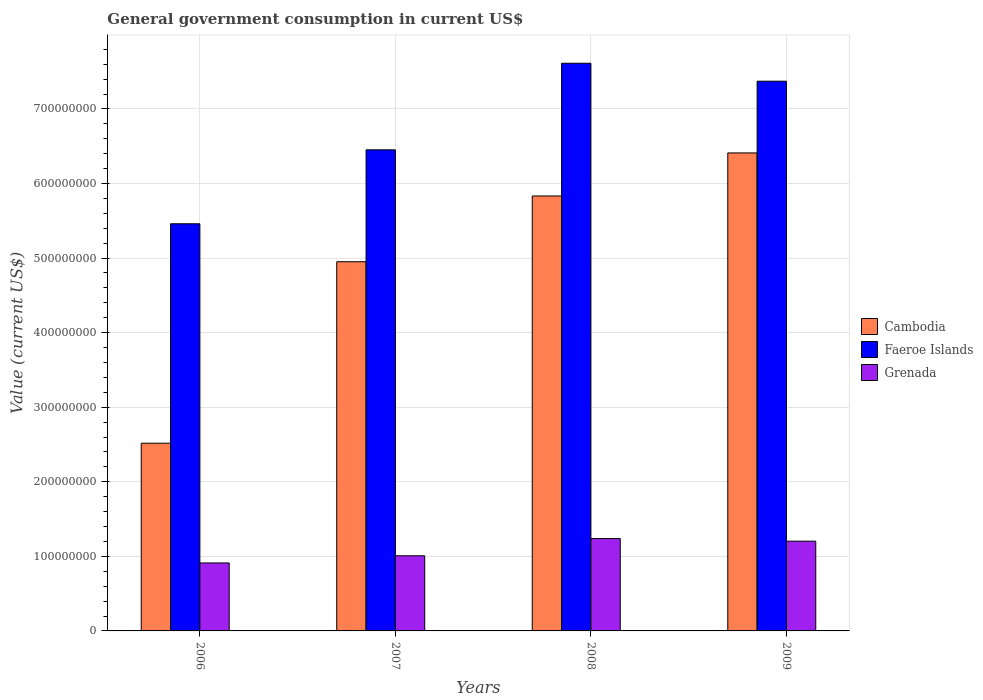How many bars are there on the 1st tick from the left?
Ensure brevity in your answer.  3. What is the label of the 3rd group of bars from the left?
Provide a short and direct response. 2008. In how many cases, is the number of bars for a given year not equal to the number of legend labels?
Provide a short and direct response. 0. What is the government conusmption in Cambodia in 2009?
Provide a short and direct response. 6.41e+08. Across all years, what is the maximum government conusmption in Faeroe Islands?
Give a very brief answer. 7.61e+08. Across all years, what is the minimum government conusmption in Cambodia?
Provide a succinct answer. 2.52e+08. In which year was the government conusmption in Cambodia minimum?
Your answer should be very brief. 2006. What is the total government conusmption in Faeroe Islands in the graph?
Your response must be concise. 2.69e+09. What is the difference between the government conusmption in Cambodia in 2006 and that in 2008?
Make the answer very short. -3.32e+08. What is the difference between the government conusmption in Faeroe Islands in 2009 and the government conusmption in Cambodia in 2006?
Your answer should be very brief. 4.85e+08. What is the average government conusmption in Cambodia per year?
Keep it short and to the point. 4.93e+08. In the year 2006, what is the difference between the government conusmption in Faeroe Islands and government conusmption in Grenada?
Your response must be concise. 4.55e+08. In how many years, is the government conusmption in Grenada greater than 140000000 US$?
Offer a terse response. 0. What is the ratio of the government conusmption in Faeroe Islands in 2006 to that in 2009?
Keep it short and to the point. 0.74. Is the government conusmption in Faeroe Islands in 2006 less than that in 2007?
Keep it short and to the point. Yes. Is the difference between the government conusmption in Faeroe Islands in 2007 and 2009 greater than the difference between the government conusmption in Grenada in 2007 and 2009?
Give a very brief answer. No. What is the difference between the highest and the second highest government conusmption in Faeroe Islands?
Your answer should be very brief. 2.41e+07. What is the difference between the highest and the lowest government conusmption in Faeroe Islands?
Give a very brief answer. 2.15e+08. What does the 2nd bar from the left in 2009 represents?
Your answer should be very brief. Faeroe Islands. What does the 1st bar from the right in 2007 represents?
Your response must be concise. Grenada. Is it the case that in every year, the sum of the government conusmption in Cambodia and government conusmption in Grenada is greater than the government conusmption in Faeroe Islands?
Provide a short and direct response. No. Are the values on the major ticks of Y-axis written in scientific E-notation?
Your answer should be compact. No. Does the graph contain any zero values?
Provide a succinct answer. No. How are the legend labels stacked?
Make the answer very short. Vertical. What is the title of the graph?
Offer a terse response. General government consumption in current US$. What is the label or title of the Y-axis?
Offer a terse response. Value (current US$). What is the Value (current US$) of Cambodia in 2006?
Keep it short and to the point. 2.52e+08. What is the Value (current US$) of Faeroe Islands in 2006?
Offer a terse response. 5.46e+08. What is the Value (current US$) in Grenada in 2006?
Offer a terse response. 9.11e+07. What is the Value (current US$) of Cambodia in 2007?
Give a very brief answer. 4.95e+08. What is the Value (current US$) of Faeroe Islands in 2007?
Give a very brief answer. 6.45e+08. What is the Value (current US$) in Grenada in 2007?
Make the answer very short. 1.01e+08. What is the Value (current US$) of Cambodia in 2008?
Your answer should be compact. 5.83e+08. What is the Value (current US$) of Faeroe Islands in 2008?
Offer a terse response. 7.61e+08. What is the Value (current US$) of Grenada in 2008?
Make the answer very short. 1.24e+08. What is the Value (current US$) in Cambodia in 2009?
Your answer should be compact. 6.41e+08. What is the Value (current US$) of Faeroe Islands in 2009?
Make the answer very short. 7.37e+08. What is the Value (current US$) in Grenada in 2009?
Give a very brief answer. 1.20e+08. Across all years, what is the maximum Value (current US$) in Cambodia?
Ensure brevity in your answer.  6.41e+08. Across all years, what is the maximum Value (current US$) in Faeroe Islands?
Ensure brevity in your answer.  7.61e+08. Across all years, what is the maximum Value (current US$) of Grenada?
Give a very brief answer. 1.24e+08. Across all years, what is the minimum Value (current US$) of Cambodia?
Keep it short and to the point. 2.52e+08. Across all years, what is the minimum Value (current US$) of Faeroe Islands?
Give a very brief answer. 5.46e+08. Across all years, what is the minimum Value (current US$) of Grenada?
Offer a very short reply. 9.11e+07. What is the total Value (current US$) in Cambodia in the graph?
Keep it short and to the point. 1.97e+09. What is the total Value (current US$) of Faeroe Islands in the graph?
Offer a very short reply. 2.69e+09. What is the total Value (current US$) in Grenada in the graph?
Provide a short and direct response. 4.36e+08. What is the difference between the Value (current US$) of Cambodia in 2006 and that in 2007?
Keep it short and to the point. -2.43e+08. What is the difference between the Value (current US$) of Faeroe Islands in 2006 and that in 2007?
Provide a short and direct response. -9.91e+07. What is the difference between the Value (current US$) in Grenada in 2006 and that in 2007?
Your answer should be compact. -9.65e+06. What is the difference between the Value (current US$) of Cambodia in 2006 and that in 2008?
Provide a short and direct response. -3.32e+08. What is the difference between the Value (current US$) in Faeroe Islands in 2006 and that in 2008?
Give a very brief answer. -2.15e+08. What is the difference between the Value (current US$) in Grenada in 2006 and that in 2008?
Your response must be concise. -3.27e+07. What is the difference between the Value (current US$) in Cambodia in 2006 and that in 2009?
Your response must be concise. -3.89e+08. What is the difference between the Value (current US$) in Faeroe Islands in 2006 and that in 2009?
Your answer should be compact. -1.91e+08. What is the difference between the Value (current US$) in Grenada in 2006 and that in 2009?
Give a very brief answer. -2.92e+07. What is the difference between the Value (current US$) of Cambodia in 2007 and that in 2008?
Make the answer very short. -8.82e+07. What is the difference between the Value (current US$) in Faeroe Islands in 2007 and that in 2008?
Keep it short and to the point. -1.16e+08. What is the difference between the Value (current US$) in Grenada in 2007 and that in 2008?
Your answer should be compact. -2.31e+07. What is the difference between the Value (current US$) in Cambodia in 2007 and that in 2009?
Give a very brief answer. -1.46e+08. What is the difference between the Value (current US$) of Faeroe Islands in 2007 and that in 2009?
Offer a terse response. -9.20e+07. What is the difference between the Value (current US$) in Grenada in 2007 and that in 2009?
Ensure brevity in your answer.  -1.96e+07. What is the difference between the Value (current US$) of Cambodia in 2008 and that in 2009?
Offer a terse response. -5.77e+07. What is the difference between the Value (current US$) in Faeroe Islands in 2008 and that in 2009?
Give a very brief answer. 2.41e+07. What is the difference between the Value (current US$) of Grenada in 2008 and that in 2009?
Provide a succinct answer. 3.51e+06. What is the difference between the Value (current US$) of Cambodia in 2006 and the Value (current US$) of Faeroe Islands in 2007?
Offer a very short reply. -3.93e+08. What is the difference between the Value (current US$) in Cambodia in 2006 and the Value (current US$) in Grenada in 2007?
Keep it short and to the point. 1.51e+08. What is the difference between the Value (current US$) in Faeroe Islands in 2006 and the Value (current US$) in Grenada in 2007?
Provide a short and direct response. 4.45e+08. What is the difference between the Value (current US$) of Cambodia in 2006 and the Value (current US$) of Faeroe Islands in 2008?
Ensure brevity in your answer.  -5.10e+08. What is the difference between the Value (current US$) of Cambodia in 2006 and the Value (current US$) of Grenada in 2008?
Offer a terse response. 1.28e+08. What is the difference between the Value (current US$) of Faeroe Islands in 2006 and the Value (current US$) of Grenada in 2008?
Provide a short and direct response. 4.22e+08. What is the difference between the Value (current US$) in Cambodia in 2006 and the Value (current US$) in Faeroe Islands in 2009?
Your answer should be compact. -4.85e+08. What is the difference between the Value (current US$) of Cambodia in 2006 and the Value (current US$) of Grenada in 2009?
Provide a short and direct response. 1.31e+08. What is the difference between the Value (current US$) of Faeroe Islands in 2006 and the Value (current US$) of Grenada in 2009?
Your answer should be very brief. 4.26e+08. What is the difference between the Value (current US$) of Cambodia in 2007 and the Value (current US$) of Faeroe Islands in 2008?
Provide a short and direct response. -2.66e+08. What is the difference between the Value (current US$) in Cambodia in 2007 and the Value (current US$) in Grenada in 2008?
Keep it short and to the point. 3.71e+08. What is the difference between the Value (current US$) in Faeroe Islands in 2007 and the Value (current US$) in Grenada in 2008?
Your response must be concise. 5.21e+08. What is the difference between the Value (current US$) in Cambodia in 2007 and the Value (current US$) in Faeroe Islands in 2009?
Provide a short and direct response. -2.42e+08. What is the difference between the Value (current US$) in Cambodia in 2007 and the Value (current US$) in Grenada in 2009?
Make the answer very short. 3.75e+08. What is the difference between the Value (current US$) in Faeroe Islands in 2007 and the Value (current US$) in Grenada in 2009?
Provide a succinct answer. 5.25e+08. What is the difference between the Value (current US$) of Cambodia in 2008 and the Value (current US$) of Faeroe Islands in 2009?
Provide a short and direct response. -1.54e+08. What is the difference between the Value (current US$) in Cambodia in 2008 and the Value (current US$) in Grenada in 2009?
Your answer should be compact. 4.63e+08. What is the difference between the Value (current US$) in Faeroe Islands in 2008 and the Value (current US$) in Grenada in 2009?
Your answer should be compact. 6.41e+08. What is the average Value (current US$) of Cambodia per year?
Your answer should be very brief. 4.93e+08. What is the average Value (current US$) of Faeroe Islands per year?
Your answer should be very brief. 6.72e+08. What is the average Value (current US$) of Grenada per year?
Provide a succinct answer. 1.09e+08. In the year 2006, what is the difference between the Value (current US$) of Cambodia and Value (current US$) of Faeroe Islands?
Provide a short and direct response. -2.94e+08. In the year 2006, what is the difference between the Value (current US$) of Cambodia and Value (current US$) of Grenada?
Offer a terse response. 1.61e+08. In the year 2006, what is the difference between the Value (current US$) of Faeroe Islands and Value (current US$) of Grenada?
Provide a short and direct response. 4.55e+08. In the year 2007, what is the difference between the Value (current US$) of Cambodia and Value (current US$) of Faeroe Islands?
Ensure brevity in your answer.  -1.50e+08. In the year 2007, what is the difference between the Value (current US$) in Cambodia and Value (current US$) in Grenada?
Offer a terse response. 3.94e+08. In the year 2007, what is the difference between the Value (current US$) in Faeroe Islands and Value (current US$) in Grenada?
Provide a succinct answer. 5.44e+08. In the year 2008, what is the difference between the Value (current US$) in Cambodia and Value (current US$) in Faeroe Islands?
Give a very brief answer. -1.78e+08. In the year 2008, what is the difference between the Value (current US$) of Cambodia and Value (current US$) of Grenada?
Your answer should be very brief. 4.59e+08. In the year 2008, what is the difference between the Value (current US$) in Faeroe Islands and Value (current US$) in Grenada?
Your response must be concise. 6.37e+08. In the year 2009, what is the difference between the Value (current US$) in Cambodia and Value (current US$) in Faeroe Islands?
Make the answer very short. -9.62e+07. In the year 2009, what is the difference between the Value (current US$) of Cambodia and Value (current US$) of Grenada?
Offer a terse response. 5.21e+08. In the year 2009, what is the difference between the Value (current US$) of Faeroe Islands and Value (current US$) of Grenada?
Ensure brevity in your answer.  6.17e+08. What is the ratio of the Value (current US$) of Cambodia in 2006 to that in 2007?
Make the answer very short. 0.51. What is the ratio of the Value (current US$) in Faeroe Islands in 2006 to that in 2007?
Give a very brief answer. 0.85. What is the ratio of the Value (current US$) in Grenada in 2006 to that in 2007?
Your answer should be very brief. 0.9. What is the ratio of the Value (current US$) in Cambodia in 2006 to that in 2008?
Keep it short and to the point. 0.43. What is the ratio of the Value (current US$) of Faeroe Islands in 2006 to that in 2008?
Provide a succinct answer. 0.72. What is the ratio of the Value (current US$) of Grenada in 2006 to that in 2008?
Offer a terse response. 0.74. What is the ratio of the Value (current US$) of Cambodia in 2006 to that in 2009?
Provide a succinct answer. 0.39. What is the ratio of the Value (current US$) of Faeroe Islands in 2006 to that in 2009?
Ensure brevity in your answer.  0.74. What is the ratio of the Value (current US$) in Grenada in 2006 to that in 2009?
Give a very brief answer. 0.76. What is the ratio of the Value (current US$) in Cambodia in 2007 to that in 2008?
Offer a terse response. 0.85. What is the ratio of the Value (current US$) in Faeroe Islands in 2007 to that in 2008?
Offer a terse response. 0.85. What is the ratio of the Value (current US$) in Grenada in 2007 to that in 2008?
Ensure brevity in your answer.  0.81. What is the ratio of the Value (current US$) of Cambodia in 2007 to that in 2009?
Provide a short and direct response. 0.77. What is the ratio of the Value (current US$) of Faeroe Islands in 2007 to that in 2009?
Make the answer very short. 0.88. What is the ratio of the Value (current US$) in Grenada in 2007 to that in 2009?
Offer a terse response. 0.84. What is the ratio of the Value (current US$) in Cambodia in 2008 to that in 2009?
Keep it short and to the point. 0.91. What is the ratio of the Value (current US$) of Faeroe Islands in 2008 to that in 2009?
Give a very brief answer. 1.03. What is the ratio of the Value (current US$) in Grenada in 2008 to that in 2009?
Offer a very short reply. 1.03. What is the difference between the highest and the second highest Value (current US$) of Cambodia?
Make the answer very short. 5.77e+07. What is the difference between the highest and the second highest Value (current US$) in Faeroe Islands?
Provide a short and direct response. 2.41e+07. What is the difference between the highest and the second highest Value (current US$) of Grenada?
Your answer should be very brief. 3.51e+06. What is the difference between the highest and the lowest Value (current US$) in Cambodia?
Provide a succinct answer. 3.89e+08. What is the difference between the highest and the lowest Value (current US$) of Faeroe Islands?
Your answer should be very brief. 2.15e+08. What is the difference between the highest and the lowest Value (current US$) in Grenada?
Keep it short and to the point. 3.27e+07. 